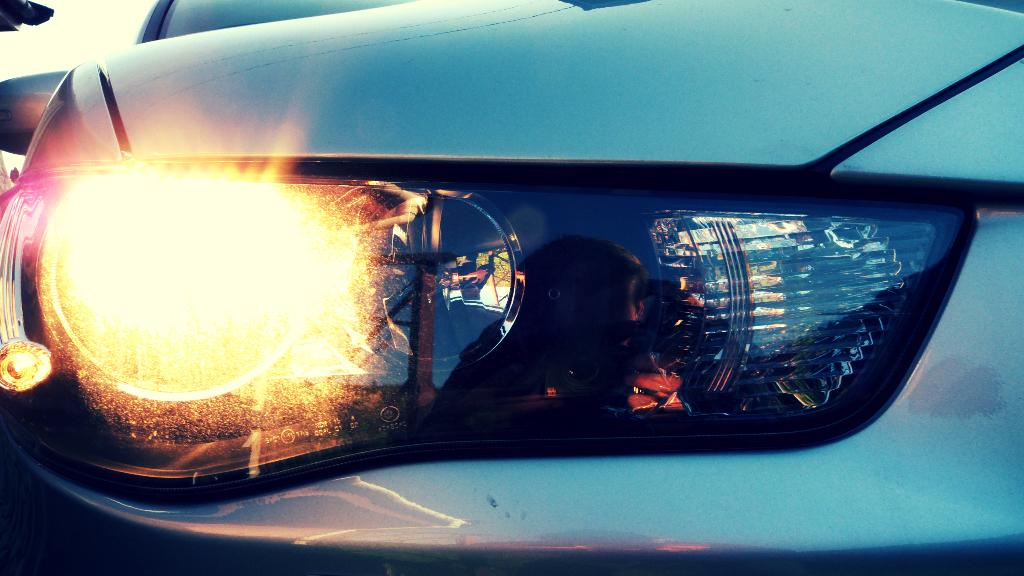What is the main subject of the image? The main subject of the image is the headlight of a car. What type of nose can be seen on the car in the image? There is no nose present on the car in the image; it is a headlight. What is the function of the pin in the image? There is no pin present in the image. 